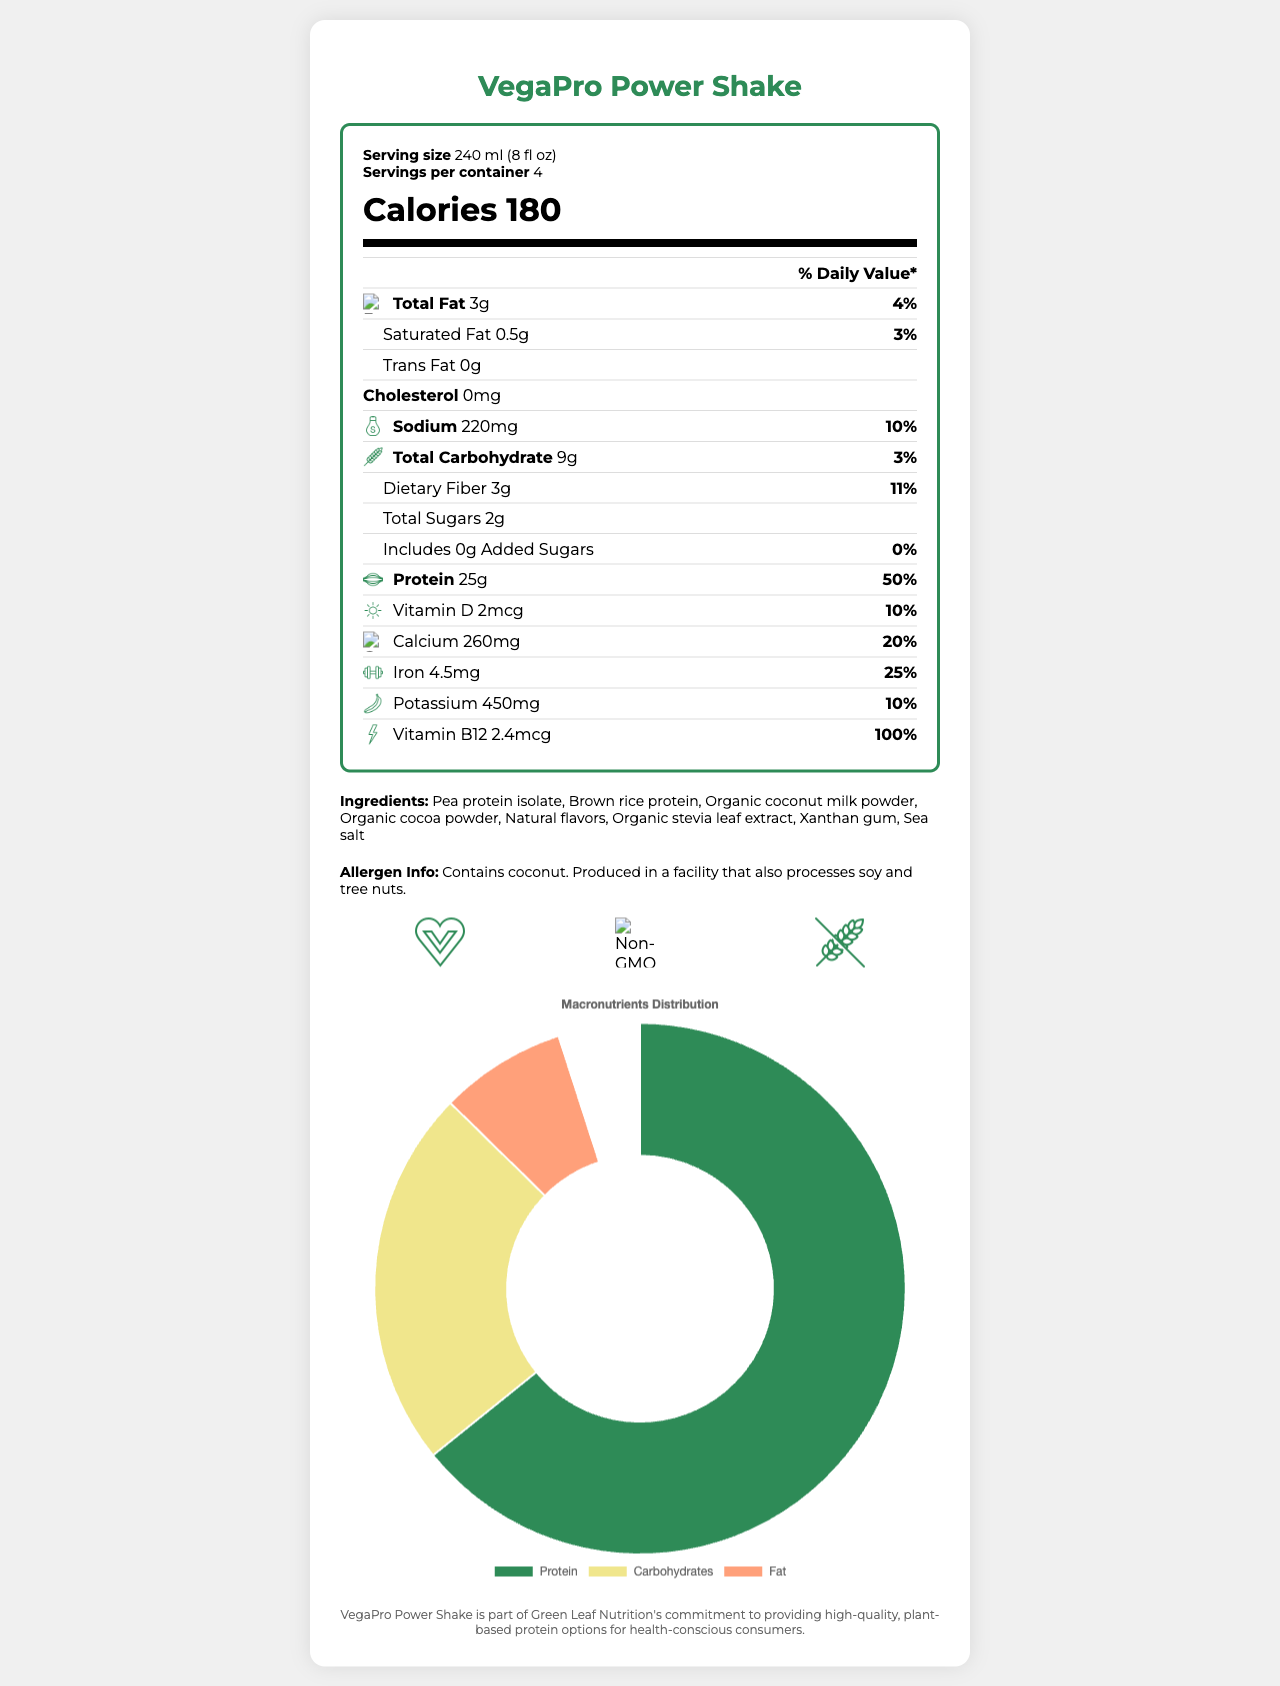what is the product name? The product name is clearly mentioned at the top of the document.
Answer: VegaPro Power Shake what is the serving size? The serving size is listed in the serving info section of the nutrition label.
Answer: 240 ml (8 fl oz) how many servings per container are there? The number of servings per container is mentioned in the serving info section of the nutrition label.
Answer: 4 how many calories are in a serving? The calorie count per serving is prominently displayed as “Calories 180” in the nutrition label.
Answer: 180 what percent daily value of protein is provided per serving? The document states, “Protein 25g” and “% Daily Value: 50%” under the protein nutrient section.
Answer: 50% what icon represents the protein content? The protein section has an icon of a muscle beside the protein content and % daily value.
Answer: Muscle which allergens does this product contain? The allergen info section mentions that the product contains coconut.
Answer: Coconut which vitamins and minerals are represented with custom icons? A. Vitamin D, Calcium, Iron, Vitamin B12 B. Vitamin A, Zinc, Magnesium, Vitamin C C. Vitamin E, Phosphorus, Folic Acid, Vitamin K The nutrients with icons in the document are Vitamin D (sun), Calcium (bone), Iron (dumbbell), and Vitamin B12 (lightning bolt).
Answer: A what is the design style of the custom icons? A. Realistic B. Minimalist line drawings C. Cartoon-style D. Abstract The document mentions that the icons have a "Minimalist line drawings" style.
Answer: B does the product contain gluten? The certification section lists the product as “Gluten-Free.”
Answer: No is this product vegan? The product is “Certified Vegan by Vegan Action” as mentioned in the certifications section.
Answer: Yes summarize the main idea of the document. The summary covers the main nutrition facts, key features, and design elements of the VegaPro Power Shake document.
Answer: VegaPro Power Shake is a vegan protein shake containing 25g of protein per serving, along with other nutrients like Vitamin D, Calcium, and Iron. The document provides detailed nutrition facts, including custom icons for key nutrients, serving size, and allergen information. It also highlights that the product is vegan, non-GMO, and gluten-free. There's a custom footer and a QR code linking to the product page. who is the manufacturer of the product? The document does not provide information about the manufacturer. The custom footer mentions Green Leaf Nutrition's commitment but does not explicitly state it as the manufacturer.
Answer: Cannot be determined 